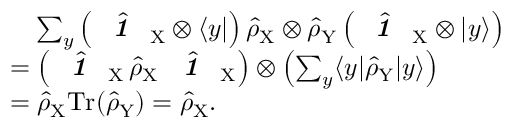<formula> <loc_0><loc_0><loc_500><loc_500>\begin{array} { r l } & { \quad \sum _ { y } \left ( \hat { 1 \, } _ { \, X } \otimes \langle y | \right ) \hat { \rho } _ { X } \otimes \hat { \rho } _ { Y } \left ( \hat { 1 \, } _ { \, X } \otimes | y \rangle \right ) } \\ & { = \left ( \hat { 1 \, } _ { \, X } \, \hat { \rho } _ { X } \, \hat { 1 \, } _ { \, X } \right ) \otimes \left ( \sum _ { y } \langle y | \hat { \rho } _ { Y } | y \rangle \right ) } \\ & { = \hat { \rho } _ { X } T r ( \hat { \rho } _ { Y } ) = \hat { \rho } _ { X } . } \end{array}</formula> 